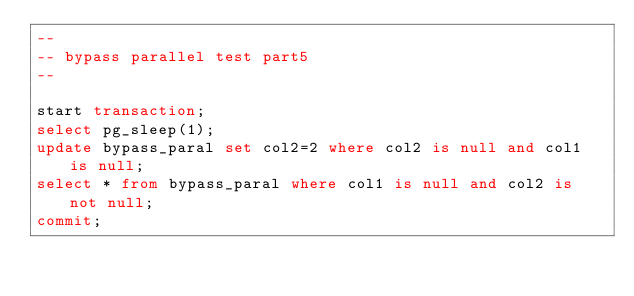<code> <loc_0><loc_0><loc_500><loc_500><_SQL_>--
-- bypass parallel test part5
--

start transaction;
select pg_sleep(1);
update bypass_paral set col2=2 where col2 is null and col1 is null;
select * from bypass_paral where col1 is null and col2 is not null;
commit;



</code> 